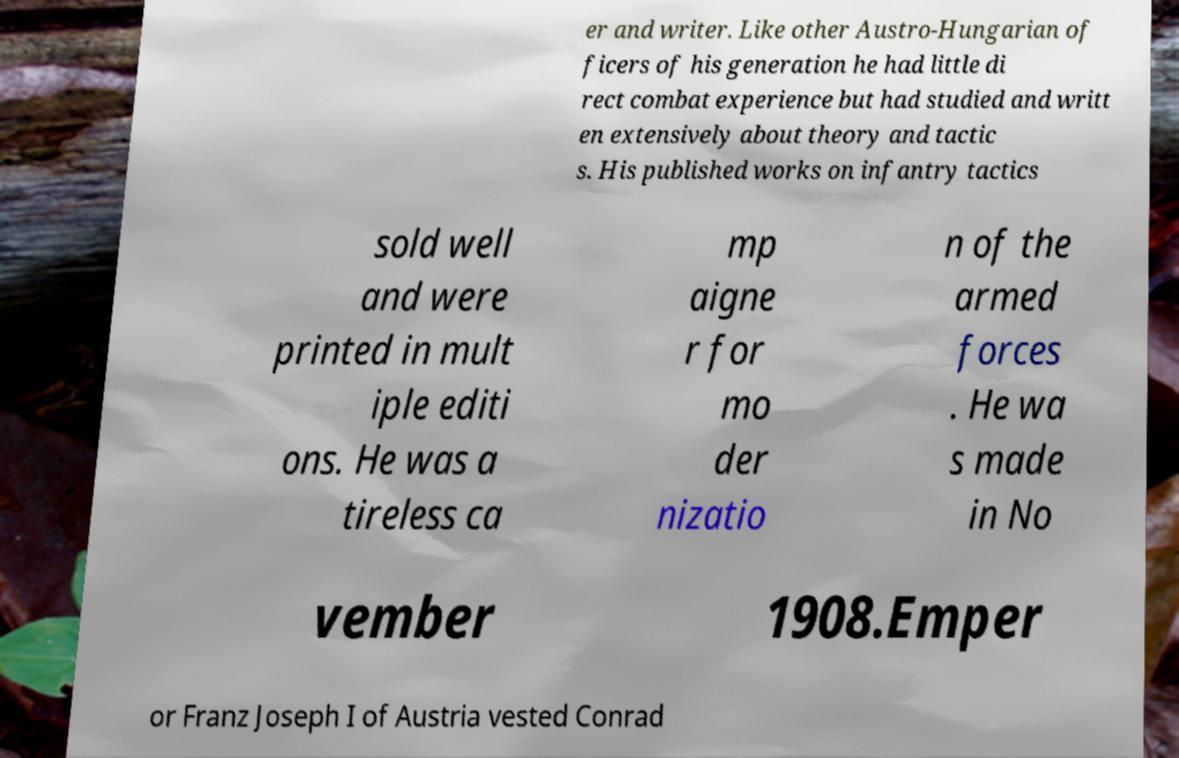I need the written content from this picture converted into text. Can you do that? er and writer. Like other Austro-Hungarian of ficers of his generation he had little di rect combat experience but had studied and writt en extensively about theory and tactic s. His published works on infantry tactics sold well and were printed in mult iple editi ons. He was a tireless ca mp aigne r for mo der nizatio n of the armed forces . He wa s made in No vember 1908.Emper or Franz Joseph I of Austria vested Conrad 